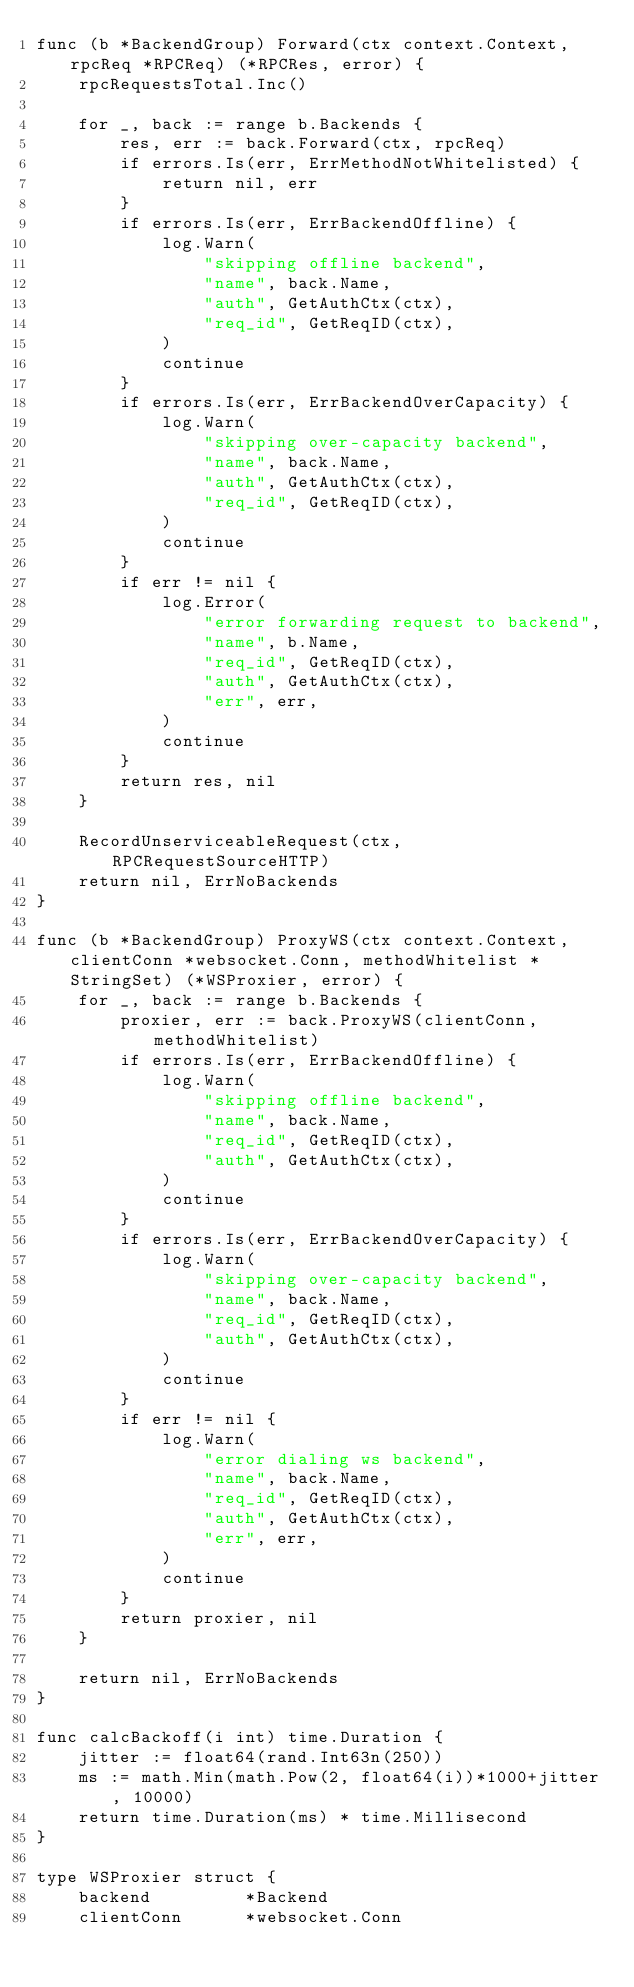<code> <loc_0><loc_0><loc_500><loc_500><_Go_>func (b *BackendGroup) Forward(ctx context.Context, rpcReq *RPCReq) (*RPCRes, error) {
	rpcRequestsTotal.Inc()

	for _, back := range b.Backends {
		res, err := back.Forward(ctx, rpcReq)
		if errors.Is(err, ErrMethodNotWhitelisted) {
			return nil, err
		}
		if errors.Is(err, ErrBackendOffline) {
			log.Warn(
				"skipping offline backend",
				"name", back.Name,
				"auth", GetAuthCtx(ctx),
				"req_id", GetReqID(ctx),
			)
			continue
		}
		if errors.Is(err, ErrBackendOverCapacity) {
			log.Warn(
				"skipping over-capacity backend",
				"name", back.Name,
				"auth", GetAuthCtx(ctx),
				"req_id", GetReqID(ctx),
			)
			continue
		}
		if err != nil {
			log.Error(
				"error forwarding request to backend",
				"name", b.Name,
				"req_id", GetReqID(ctx),
				"auth", GetAuthCtx(ctx),
				"err", err,
			)
			continue
		}
		return res, nil
	}

	RecordUnserviceableRequest(ctx, RPCRequestSourceHTTP)
	return nil, ErrNoBackends
}

func (b *BackendGroup) ProxyWS(ctx context.Context, clientConn *websocket.Conn, methodWhitelist *StringSet) (*WSProxier, error) {
	for _, back := range b.Backends {
		proxier, err := back.ProxyWS(clientConn, methodWhitelist)
		if errors.Is(err, ErrBackendOffline) {
			log.Warn(
				"skipping offline backend",
				"name", back.Name,
				"req_id", GetReqID(ctx),
				"auth", GetAuthCtx(ctx),
			)
			continue
		}
		if errors.Is(err, ErrBackendOverCapacity) {
			log.Warn(
				"skipping over-capacity backend",
				"name", back.Name,
				"req_id", GetReqID(ctx),
				"auth", GetAuthCtx(ctx),
			)
			continue
		}
		if err != nil {
			log.Warn(
				"error dialing ws backend",
				"name", back.Name,
				"req_id", GetReqID(ctx),
				"auth", GetAuthCtx(ctx),
				"err", err,
			)
			continue
		}
		return proxier, nil
	}

	return nil, ErrNoBackends
}

func calcBackoff(i int) time.Duration {
	jitter := float64(rand.Int63n(250))
	ms := math.Min(math.Pow(2, float64(i))*1000+jitter, 10000)
	return time.Duration(ms) * time.Millisecond
}

type WSProxier struct {
	backend         *Backend
	clientConn      *websocket.Conn</code> 